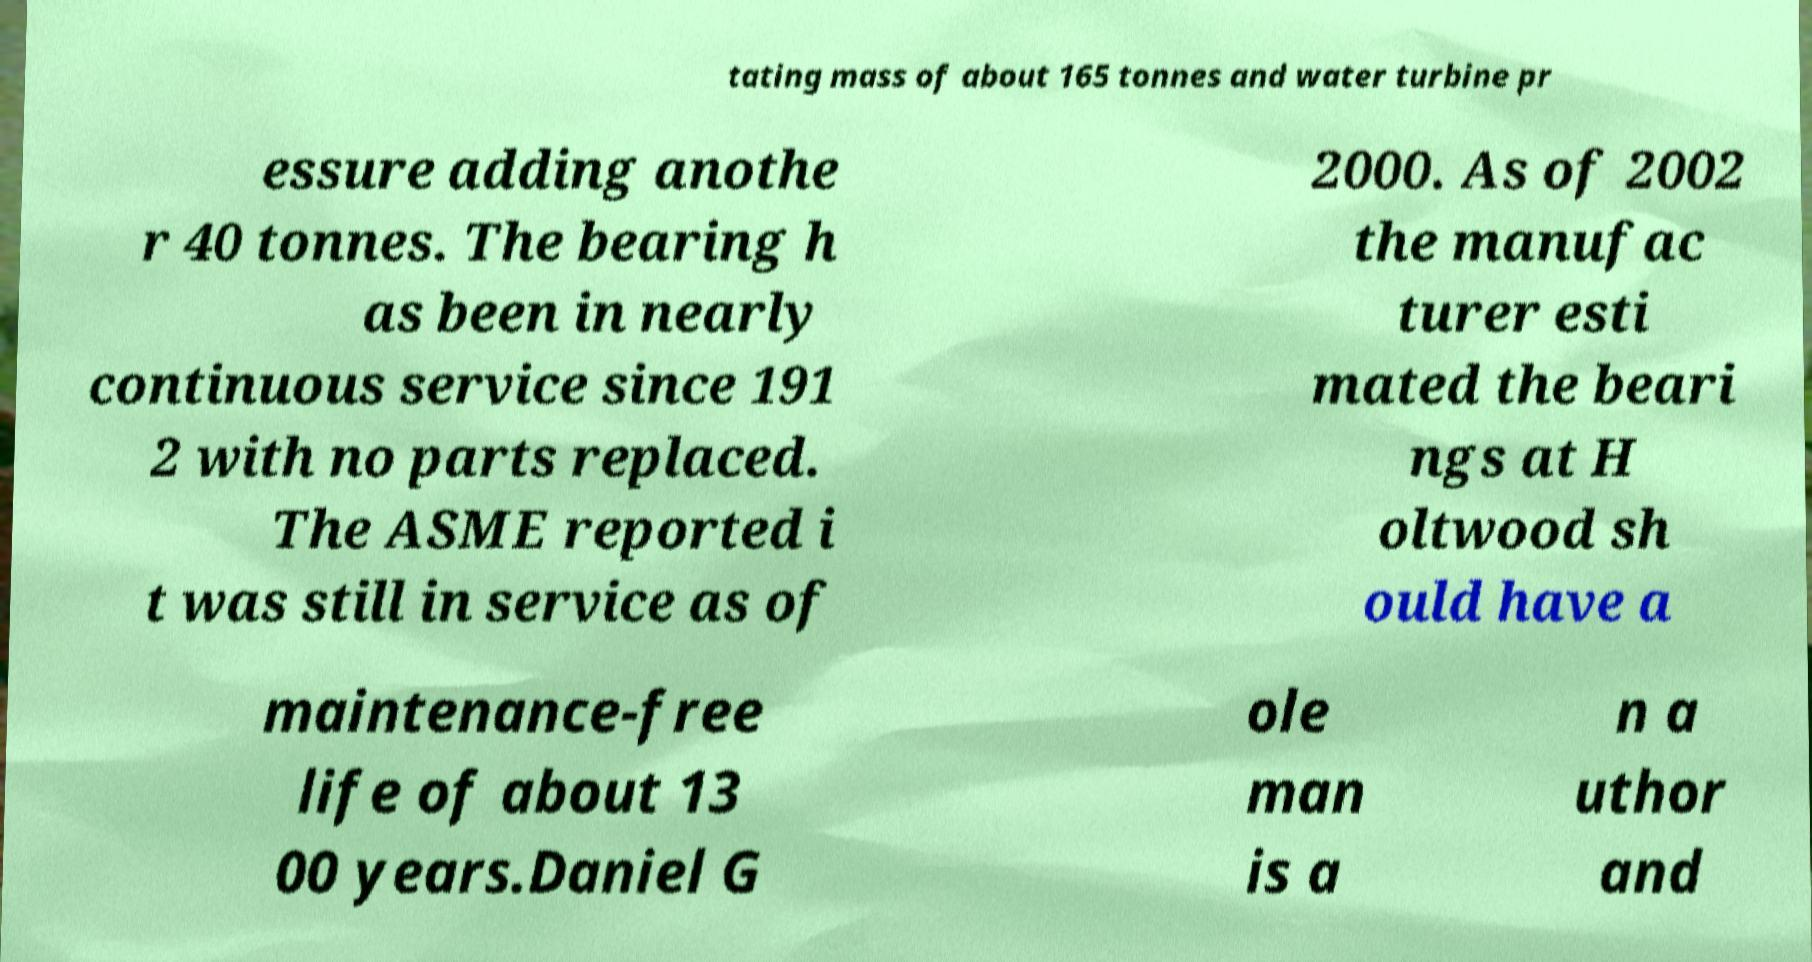There's text embedded in this image that I need extracted. Can you transcribe it verbatim? tating mass of about 165 tonnes and water turbine pr essure adding anothe r 40 tonnes. The bearing h as been in nearly continuous service since 191 2 with no parts replaced. The ASME reported i t was still in service as of 2000. As of 2002 the manufac turer esti mated the beari ngs at H oltwood sh ould have a maintenance-free life of about 13 00 years.Daniel G ole man is a n a uthor and 